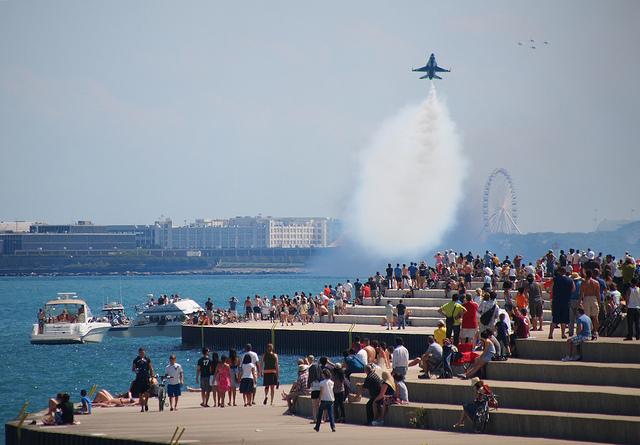What are most of the people sitting on?
Keep it brief. Steps. In what season was this picture taken?
Write a very short answer. Summer. Is this an airshow?
Keep it brief. Yes. 